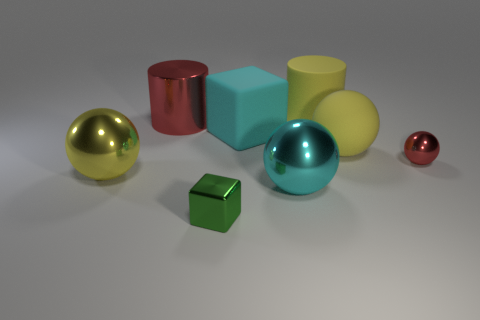There is a rubber thing that is the same color as the matte ball; what size is it?
Your response must be concise. Large. Does the red object in front of the rubber sphere have the same material as the cube that is behind the tiny shiny ball?
Make the answer very short. No. There is a ball that is the same color as the large rubber cube; what is its material?
Give a very brief answer. Metal. How many small red metallic objects are the same shape as the large red shiny thing?
Give a very brief answer. 0. Are there more yellow metallic spheres that are left of the yellow metal object than small green metallic cylinders?
Your response must be concise. No. The yellow object that is left of the yellow rubber cylinder that is behind the large sphere behind the red ball is what shape?
Your answer should be compact. Sphere. Does the yellow thing to the left of the tiny green cube have the same shape as the small object that is to the right of the cyan metal ball?
Your response must be concise. Yes. Is there any other thing that has the same size as the green metallic block?
Offer a very short reply. Yes. How many blocks are green rubber objects or large red metallic objects?
Give a very brief answer. 0. Is the small green cube made of the same material as the big red cylinder?
Offer a terse response. Yes. 